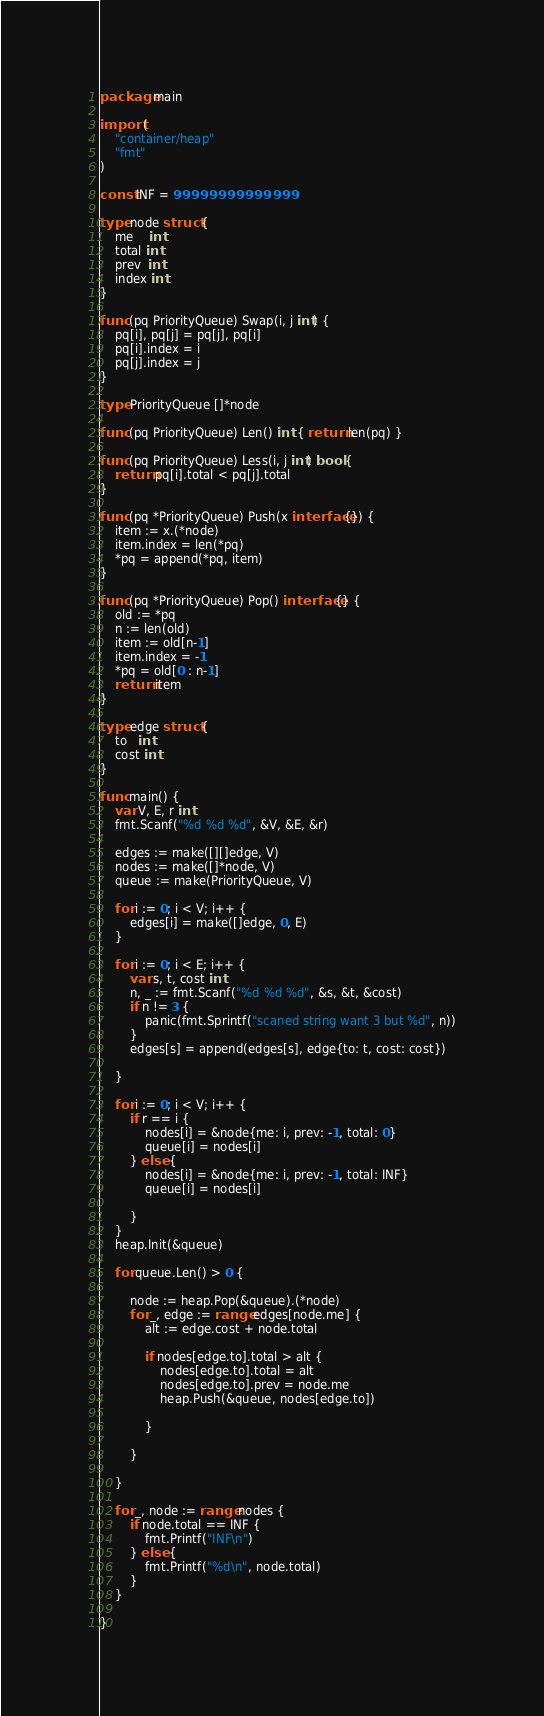Convert code to text. <code><loc_0><loc_0><loc_500><loc_500><_Go_>package main

import (
	"container/heap"
	"fmt"
)

const INF = 99999999999999

type node struct {
	me    int
	total int
	prev  int
	index int
}

func (pq PriorityQueue) Swap(i, j int) {
	pq[i], pq[j] = pq[j], pq[i]
	pq[i].index = i
	pq[j].index = j
}

type PriorityQueue []*node

func (pq PriorityQueue) Len() int { return len(pq) }

func (pq PriorityQueue) Less(i, j int) bool {
	return pq[i].total < pq[j].total
}

func (pq *PriorityQueue) Push(x interface{}) {
	item := x.(*node)
	item.index = len(*pq)
	*pq = append(*pq, item)
}

func (pq *PriorityQueue) Pop() interface{} {
	old := *pq
	n := len(old)
	item := old[n-1]
	item.index = -1
	*pq = old[0 : n-1]
	return item
}

type edge struct {
	to   int
	cost int
}

func main() {
	var V, E, r int
	fmt.Scanf("%d %d %d", &V, &E, &r)

	edges := make([][]edge, V)
	nodes := make([]*node, V)
	queue := make(PriorityQueue, V)
	
	for i := 0; i < V; i++ {
	    edges[i] = make([]edge, 0, E)
	}
	
	for i := 0; i < E; i++ {
		var s, t, cost int
		n, _ := fmt.Scanf("%d %d %d", &s, &t, &cost)
		if n != 3 {
			panic(fmt.Sprintf("scaned string want 3 but %d", n))
		}
		edges[s] = append(edges[s], edge{to: t, cost: cost})

	}

	for i := 0; i < V; i++ {
		if r == i {
			nodes[i] = &node{me: i, prev: -1, total: 0}
			queue[i] = nodes[i]
		} else {
			nodes[i] = &node{me: i, prev: -1, total: INF}
			queue[i] = nodes[i]

		}
	}
	heap.Init(&queue)

	for queue.Len() > 0 {

		node := heap.Pop(&queue).(*node)
		for _, edge := range edges[node.me] {
			alt := edge.cost + node.total

			if nodes[edge.to].total > alt {
				nodes[edge.to].total = alt
				nodes[edge.to].prev = node.me
				heap.Push(&queue, nodes[edge.to])

			}

		}

	}

	for _, node := range nodes {
		if node.total == INF {
			fmt.Printf("INF\n")
		} else {
			fmt.Printf("%d\n", node.total)
		}
	}

}

</code> 